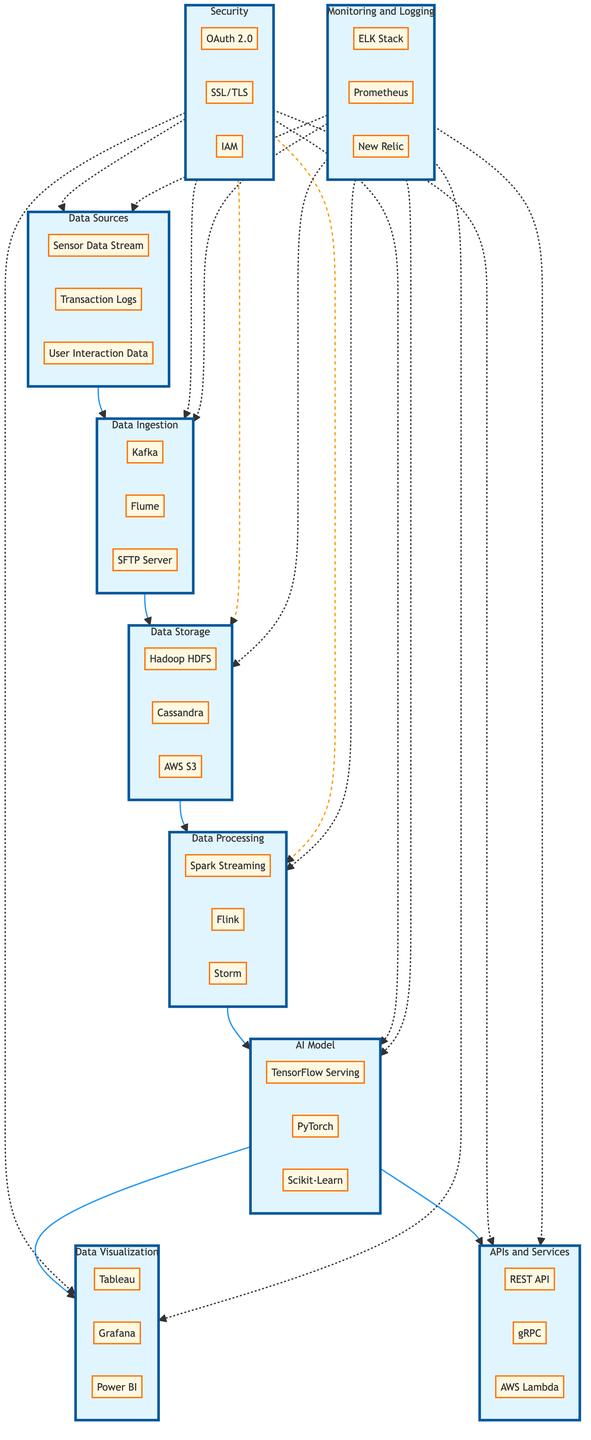What are the three components in Data Sources? The Data Sources section contains three components, which are Sensor Data Stream, Transaction Logs, and User Interaction Data.
Answer: Sensor Data Stream, Transaction Logs, User Interaction Data How many components are there in Data Processing? In the Data Processing section, there are three components: Spark Streaming, Flink, and Storm, totaling three components.
Answer: 3 Which component is responsible for real-time data processing? Spark Streaming is specifically designed for real-time data processing as indicated in the Data Processing section of the diagram.
Answer: Spark Streaming What type of service is AWS S3 classified as? AWS S3 is classified as a Cloud Storage Service in the Data Storage section, as stated within its corresponding node.
Answer: Cloud Storage Service Which two sections connect to the AI Model section? Both Data Processing and APIs and Services sections connect to the AI Model section, indicating the flow of data towards model usage and service availability.
Answer: Data Processing and APIs and Services How does Security interact with Data Ingestion? Security interacts with Data Ingestion in a dotted line indicating an indirect relationship, which shows that security measures are applied to Data Ingestion but not directly connected like other sections.
Answer: Indirectly What are the three visualization tools mentioned in the Data Visualization section? The visualization tools in the Data Visualization section are Tableau, Grafana, and Power BI, listed under that category.
Answer: Tableau, Grafana, Power BI Which is the only encryption component listed under Security? The only encryption component listed under Security is SSL/TLS, as highlighted in the respective section of the diagram.
Answer: SSL/TLS What two processing frameworks are in the Data Processing section alongside Spark Streaming? The two processing frameworks alongside Spark Streaming in the Data Processing section are Flink and Storm, as indicated in the components list.
Answer: Flink and Storm 